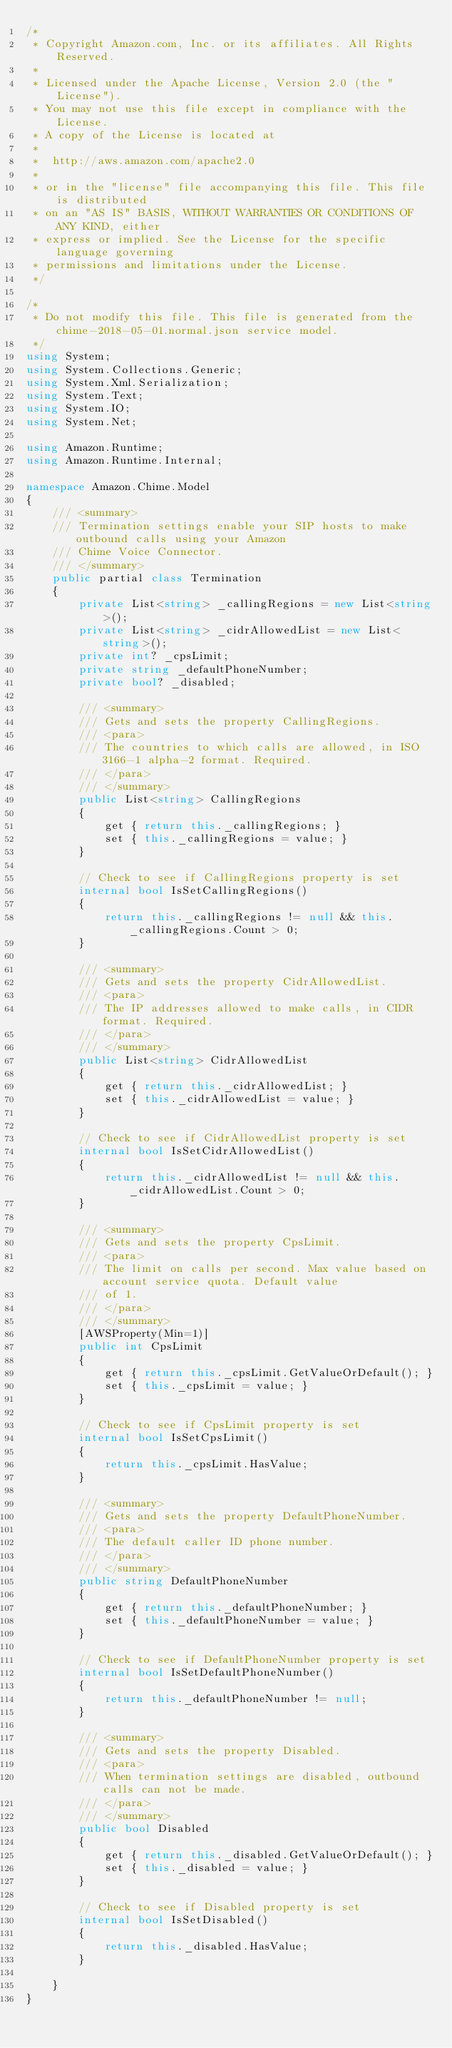<code> <loc_0><loc_0><loc_500><loc_500><_C#_>/*
 * Copyright Amazon.com, Inc. or its affiliates. All Rights Reserved.
 * 
 * Licensed under the Apache License, Version 2.0 (the "License").
 * You may not use this file except in compliance with the License.
 * A copy of the License is located at
 * 
 *  http://aws.amazon.com/apache2.0
 * 
 * or in the "license" file accompanying this file. This file is distributed
 * on an "AS IS" BASIS, WITHOUT WARRANTIES OR CONDITIONS OF ANY KIND, either
 * express or implied. See the License for the specific language governing
 * permissions and limitations under the License.
 */

/*
 * Do not modify this file. This file is generated from the chime-2018-05-01.normal.json service model.
 */
using System;
using System.Collections.Generic;
using System.Xml.Serialization;
using System.Text;
using System.IO;
using System.Net;

using Amazon.Runtime;
using Amazon.Runtime.Internal;

namespace Amazon.Chime.Model
{
    /// <summary>
    /// Termination settings enable your SIP hosts to make outbound calls using your Amazon
    /// Chime Voice Connector.
    /// </summary>
    public partial class Termination
    {
        private List<string> _callingRegions = new List<string>();
        private List<string> _cidrAllowedList = new List<string>();
        private int? _cpsLimit;
        private string _defaultPhoneNumber;
        private bool? _disabled;

        /// <summary>
        /// Gets and sets the property CallingRegions. 
        /// <para>
        /// The countries to which calls are allowed, in ISO 3166-1 alpha-2 format. Required.
        /// </para>
        /// </summary>
        public List<string> CallingRegions
        {
            get { return this._callingRegions; }
            set { this._callingRegions = value; }
        }

        // Check to see if CallingRegions property is set
        internal bool IsSetCallingRegions()
        {
            return this._callingRegions != null && this._callingRegions.Count > 0; 
        }

        /// <summary>
        /// Gets and sets the property CidrAllowedList. 
        /// <para>
        /// The IP addresses allowed to make calls, in CIDR format. Required.
        /// </para>
        /// </summary>
        public List<string> CidrAllowedList
        {
            get { return this._cidrAllowedList; }
            set { this._cidrAllowedList = value; }
        }

        // Check to see if CidrAllowedList property is set
        internal bool IsSetCidrAllowedList()
        {
            return this._cidrAllowedList != null && this._cidrAllowedList.Count > 0; 
        }

        /// <summary>
        /// Gets and sets the property CpsLimit. 
        /// <para>
        /// The limit on calls per second. Max value based on account service quota. Default value
        /// of 1.
        /// </para>
        /// </summary>
        [AWSProperty(Min=1)]
        public int CpsLimit
        {
            get { return this._cpsLimit.GetValueOrDefault(); }
            set { this._cpsLimit = value; }
        }

        // Check to see if CpsLimit property is set
        internal bool IsSetCpsLimit()
        {
            return this._cpsLimit.HasValue; 
        }

        /// <summary>
        /// Gets and sets the property DefaultPhoneNumber. 
        /// <para>
        /// The default caller ID phone number.
        /// </para>
        /// </summary>
        public string DefaultPhoneNumber
        {
            get { return this._defaultPhoneNumber; }
            set { this._defaultPhoneNumber = value; }
        }

        // Check to see if DefaultPhoneNumber property is set
        internal bool IsSetDefaultPhoneNumber()
        {
            return this._defaultPhoneNumber != null;
        }

        /// <summary>
        /// Gets and sets the property Disabled. 
        /// <para>
        /// When termination settings are disabled, outbound calls can not be made.
        /// </para>
        /// </summary>
        public bool Disabled
        {
            get { return this._disabled.GetValueOrDefault(); }
            set { this._disabled = value; }
        }

        // Check to see if Disabled property is set
        internal bool IsSetDisabled()
        {
            return this._disabled.HasValue; 
        }

    }
}</code> 